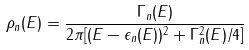<formula> <loc_0><loc_0><loc_500><loc_500>\rho _ { n } ( E ) = \frac { \Gamma _ { n } ( E ) } { 2 \pi [ ( E - \epsilon _ { n } ( E ) ) ^ { 2 } + \Gamma _ { n } ^ { 2 } ( E ) / 4 ] }</formula> 